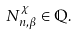Convert formula to latex. <formula><loc_0><loc_0><loc_500><loc_500>N _ { n , \beta } ^ { \chi } \in \mathbb { Q } .</formula> 